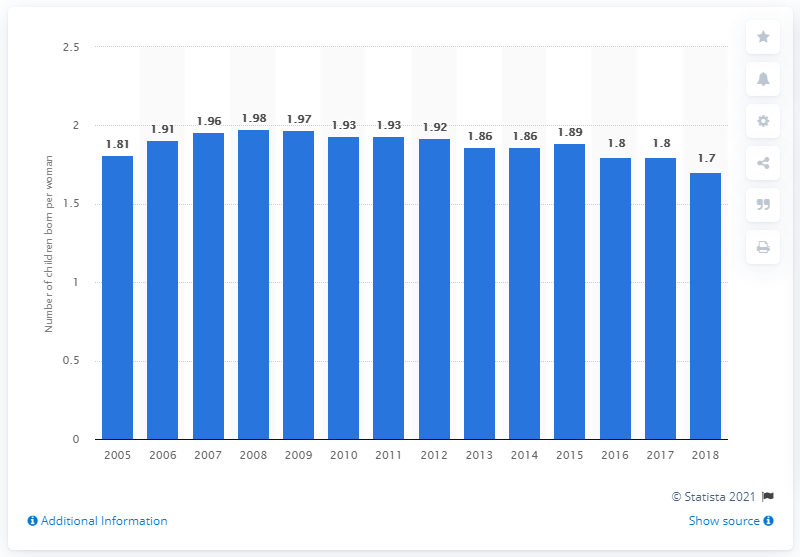Point out several critical features in this image. In 2018, the average fertility rate in Australia was 1.7 children per woman, according to data released by the Australian Bureau of Statistics. 